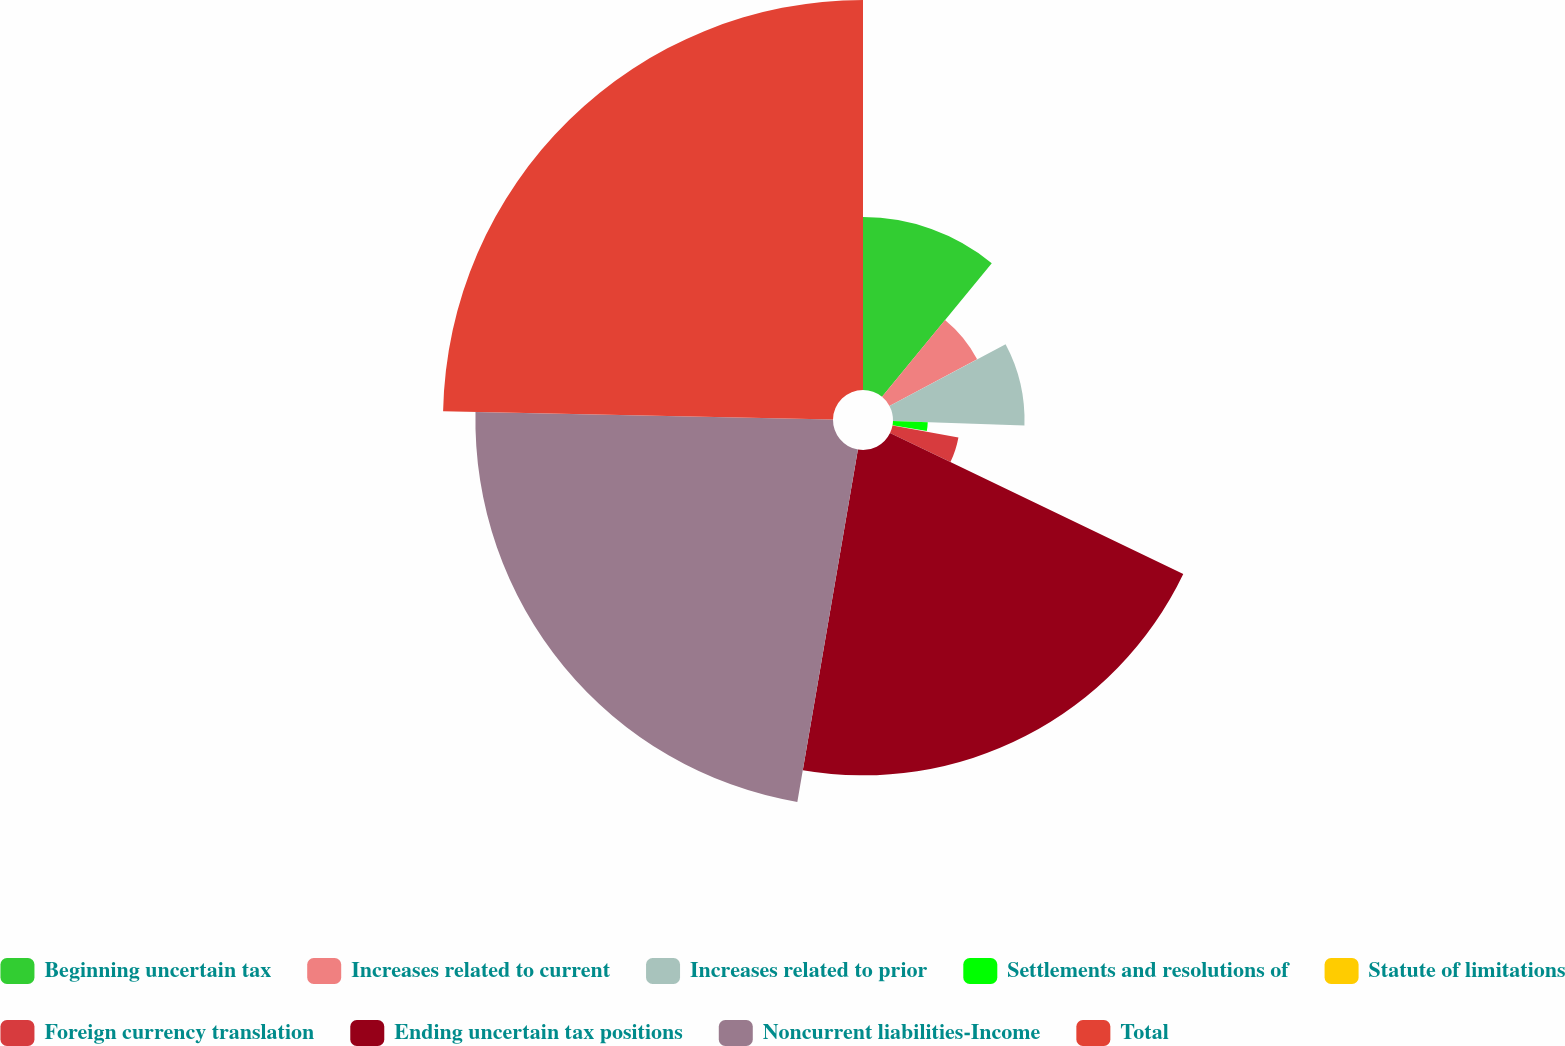<chart> <loc_0><loc_0><loc_500><loc_500><pie_chart><fcel>Beginning uncertain tax<fcel>Increases related to current<fcel>Increases related to prior<fcel>Settlements and resolutions of<fcel>Statute of limitations<fcel>Foreign currency translation<fcel>Ending uncertain tax positions<fcel>Noncurrent liabilities-Income<fcel>Total<nl><fcel>10.94%<fcel>6.28%<fcel>8.32%<fcel>2.2%<fcel>0.15%<fcel>4.24%<fcel>20.58%<fcel>22.62%<fcel>24.67%<nl></chart> 